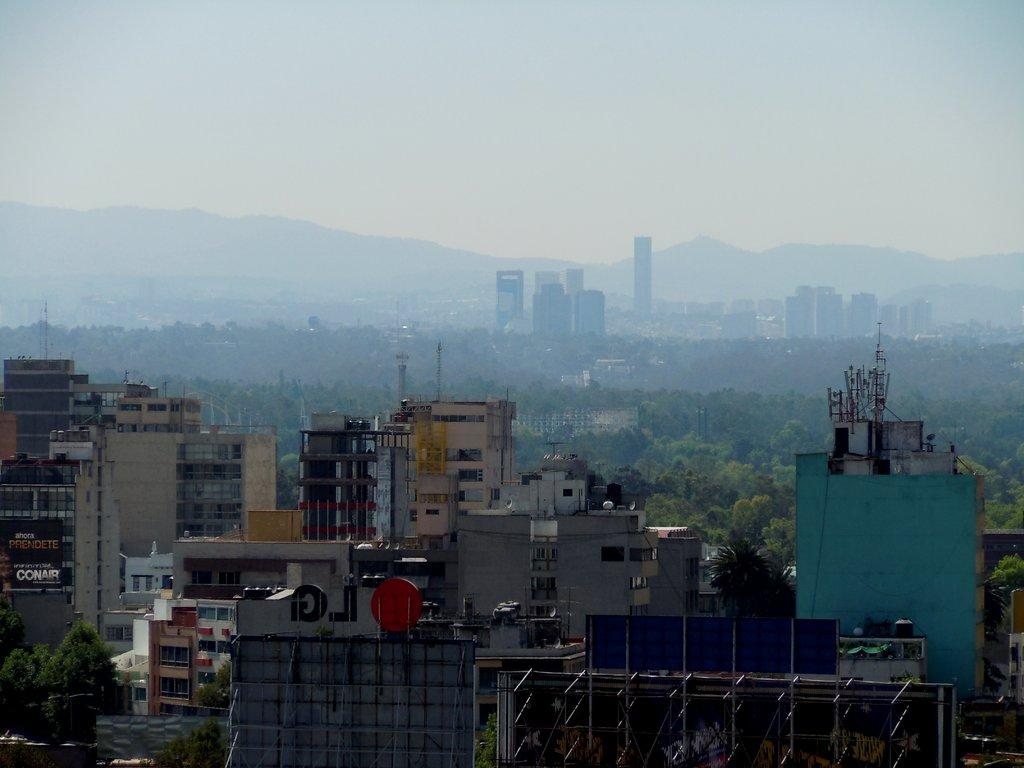What types of structures are visible in the image? There are multiple buildings in the image. What other natural elements can be seen in the image? There are trees in the image. Are there any signs or notices visible in the image? Yes, there are boards with writing in the image. How many snails can be seen climbing on the buildings in the image? There are no snails visible in the image; it only features buildings, trees, and boards with writing. 